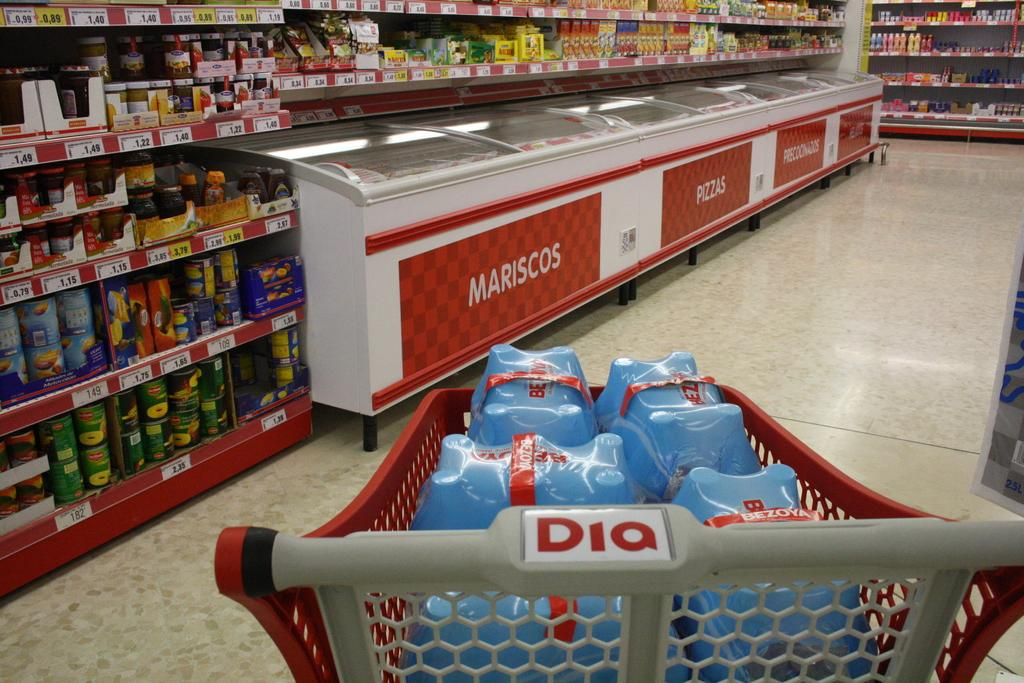Provide a one-sentence caption for the provided image. A supermarket shopper heads toward freezer cases containing mariscos and pizzas. 